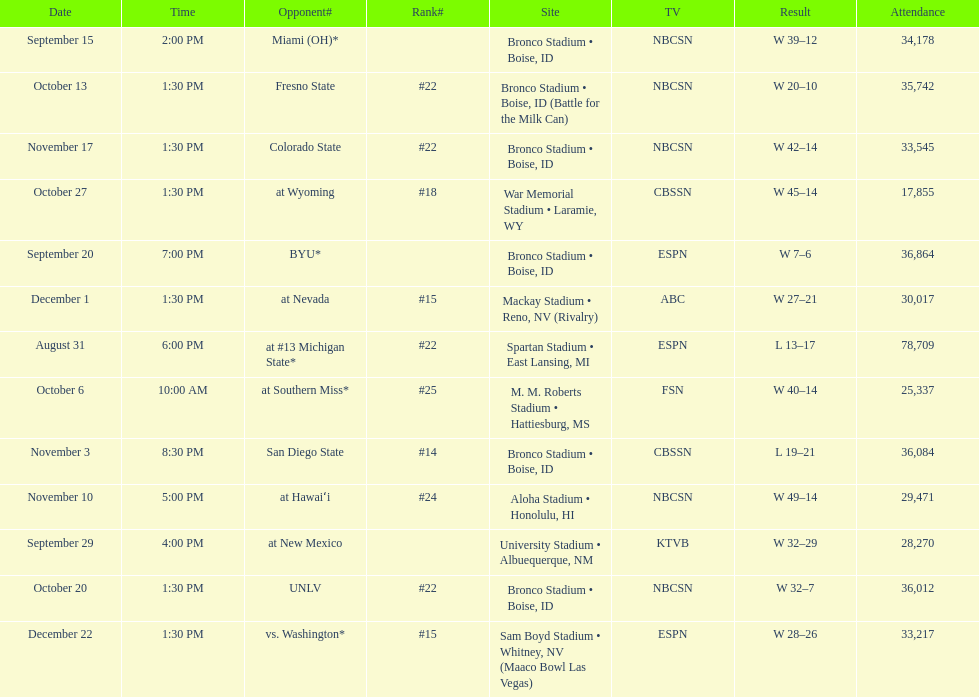Opponent broncos faced next after unlv Wyoming. 